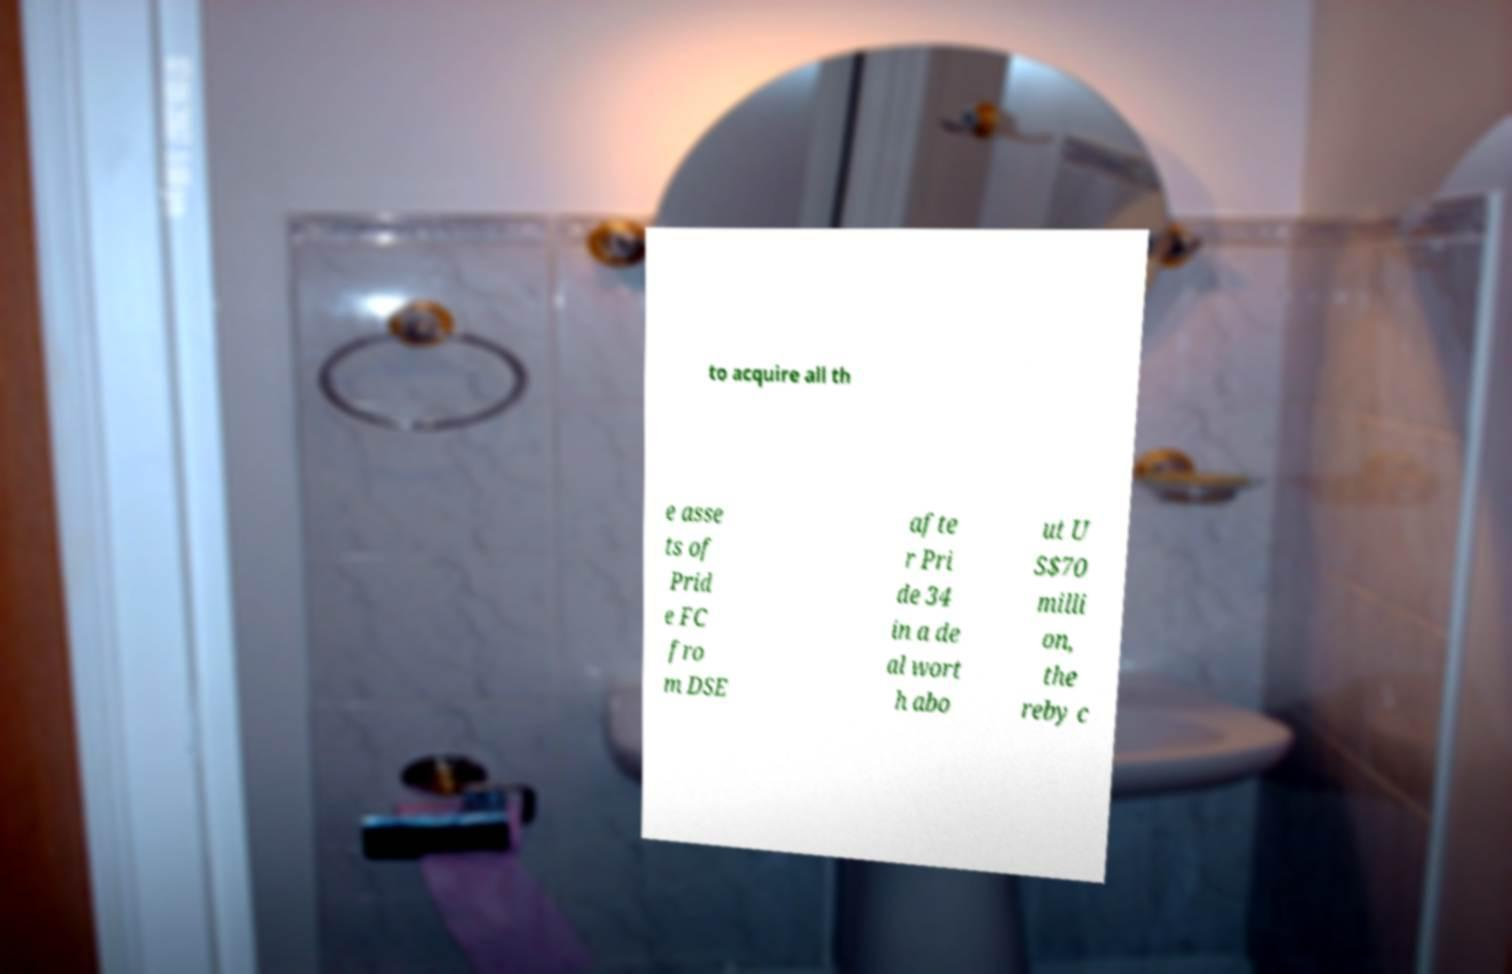Could you assist in decoding the text presented in this image and type it out clearly? to acquire all th e asse ts of Prid e FC fro m DSE afte r Pri de 34 in a de al wort h abo ut U S$70 milli on, the reby c 